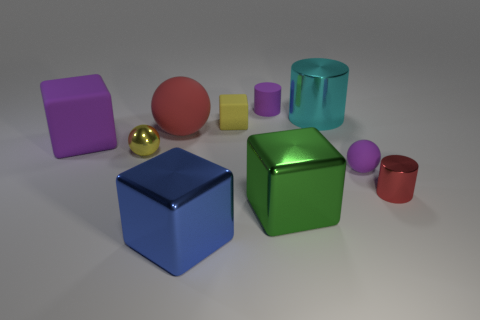Subtract 1 blocks. How many blocks are left? 3 Subtract all spheres. How many objects are left? 7 Subtract all small gray metal blocks. Subtract all tiny purple matte things. How many objects are left? 8 Add 1 tiny purple matte things. How many tiny purple matte things are left? 3 Add 1 large green things. How many large green things exist? 2 Subtract 1 cyan cylinders. How many objects are left? 9 